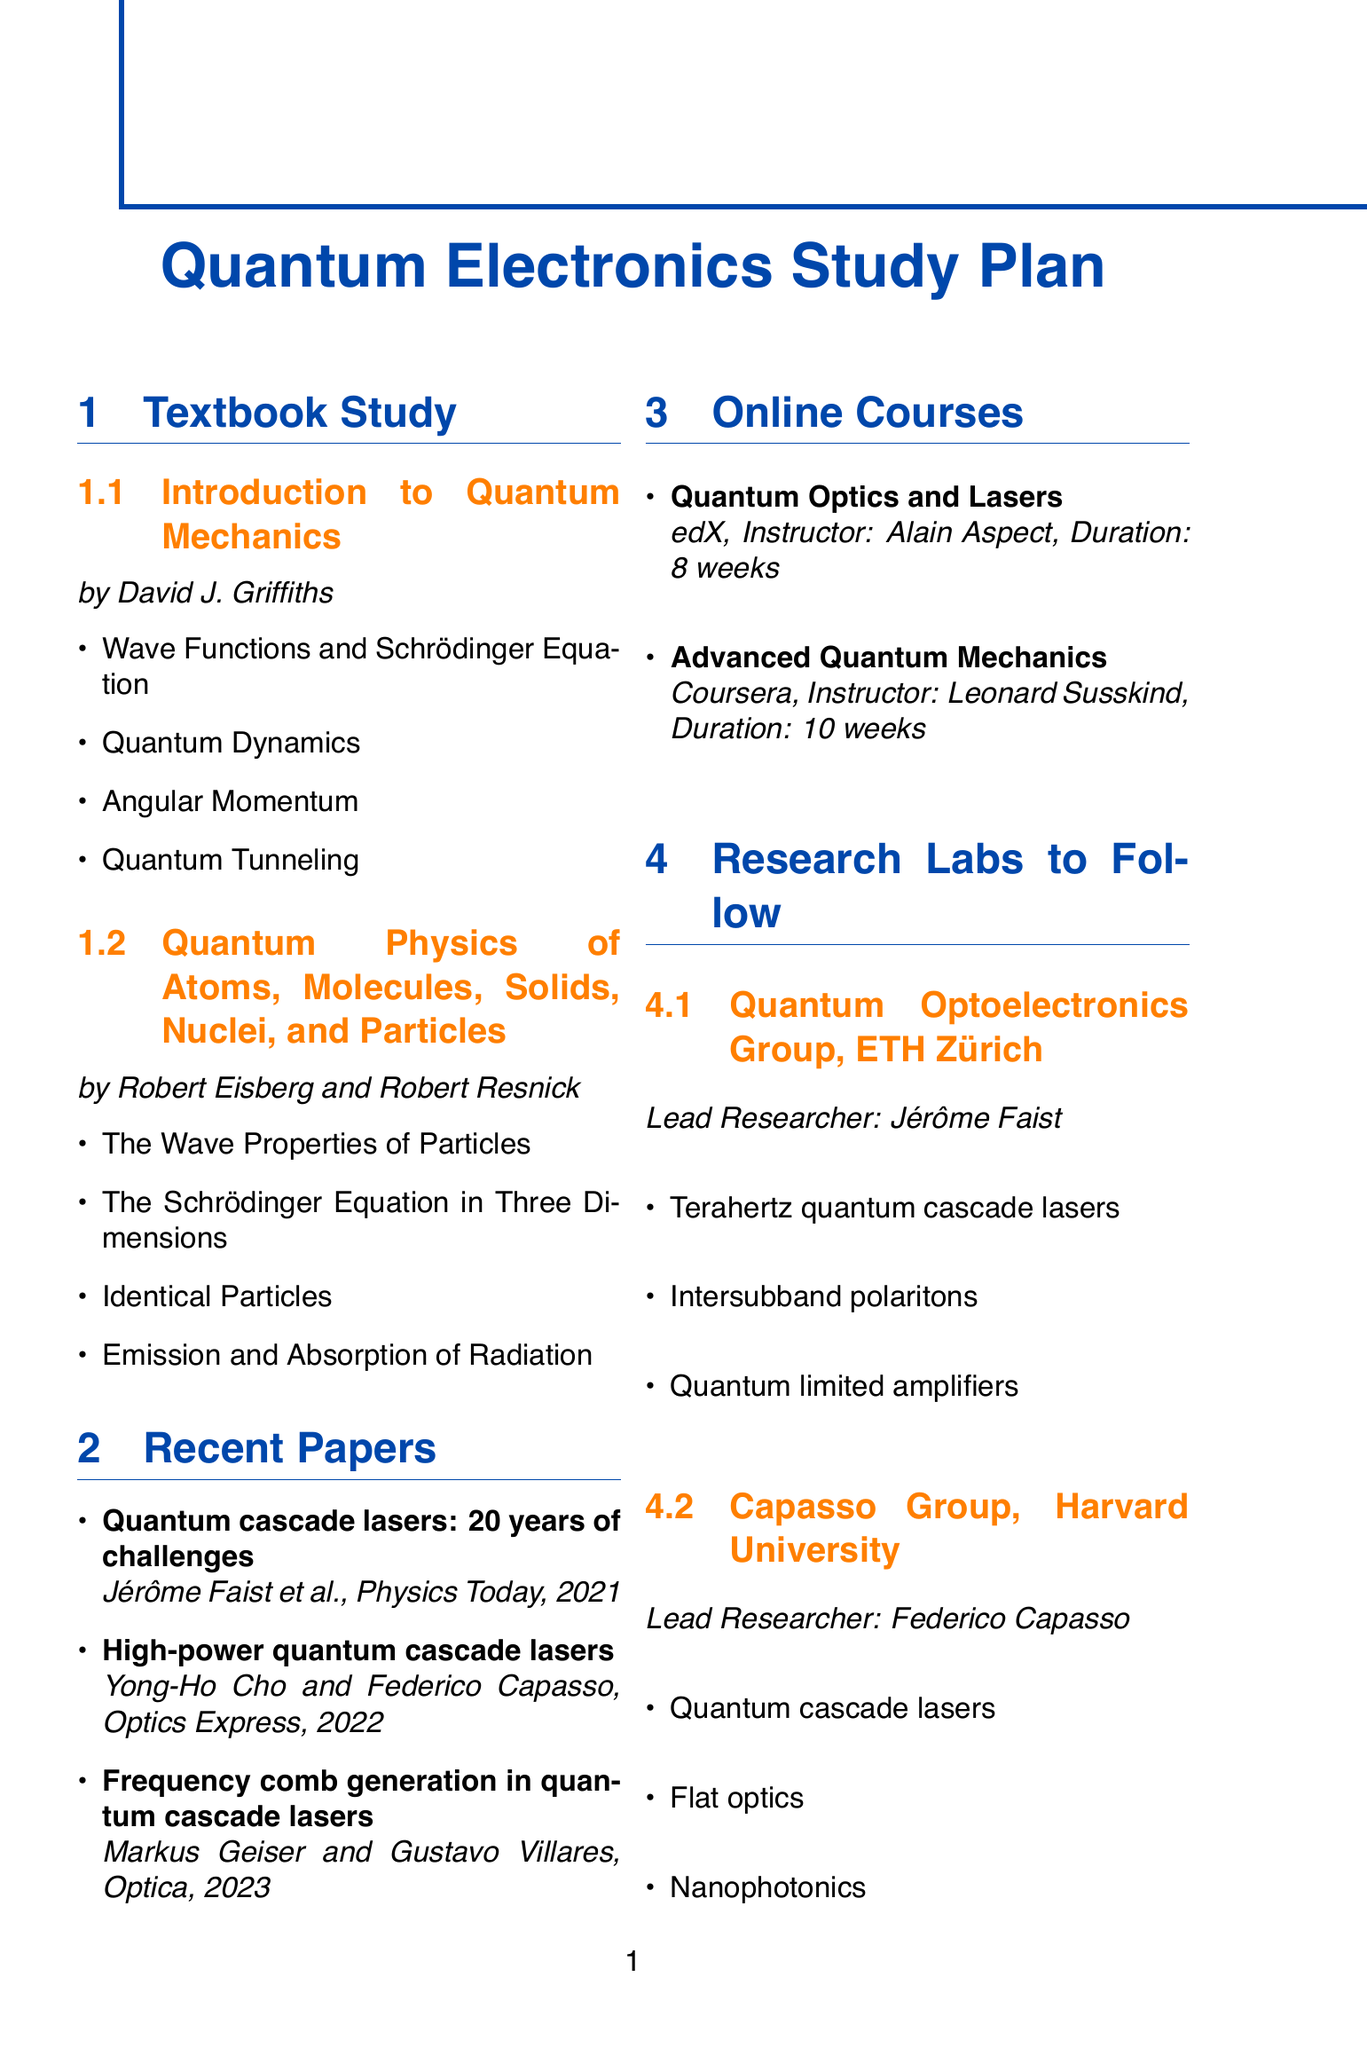what is the title of the first textbook? The title of the first textbook is listed at the beginning of the 'Textbook Study' section.
Answer: Introduction to Quantum Mechanics who is the author of the second textbook? The author's name is provided next to the title of the second textbook in the same section.
Answer: Robert Eisberg and Robert Resnick how many weeks is the "Quantum Optics and Lasers" course? The duration of the course is mentioned directly under its title in the 'Online Courses' section.
Answer: 8 weeks which paper discusses high-power quantum cascade lasers? The papers are listed under the 'Recent Papers' section, with their titles and authors.
Answer: High-power quantum cascade lasers what is the lead researcher's name at ETH Zürich? The lead researcher's name is stated under the 'Research Labs to Follow' section for the Quantum Optoelectronics Group.
Answer: Jérôme Faist when is the International Quantum Cascade Lasers School and Workshop scheduled? The date of the conference is noted in the 'Upcoming Conferences' section under its name.
Answer: September 2024 which two key topics are covered in the CLEO conference? The key topics are listed beneath the conference title in the document, indicating the main focuses of the event.
Answer: Quantum optics, Semiconductor lasers how many chapters does "Quantum Physics of Atoms, Molecules, Solids, Nuclei, and Particles" include? The total number of chapters included is directly stated in the 'Textbook Study' section below the textbook title.
Answer: 4 chapters 